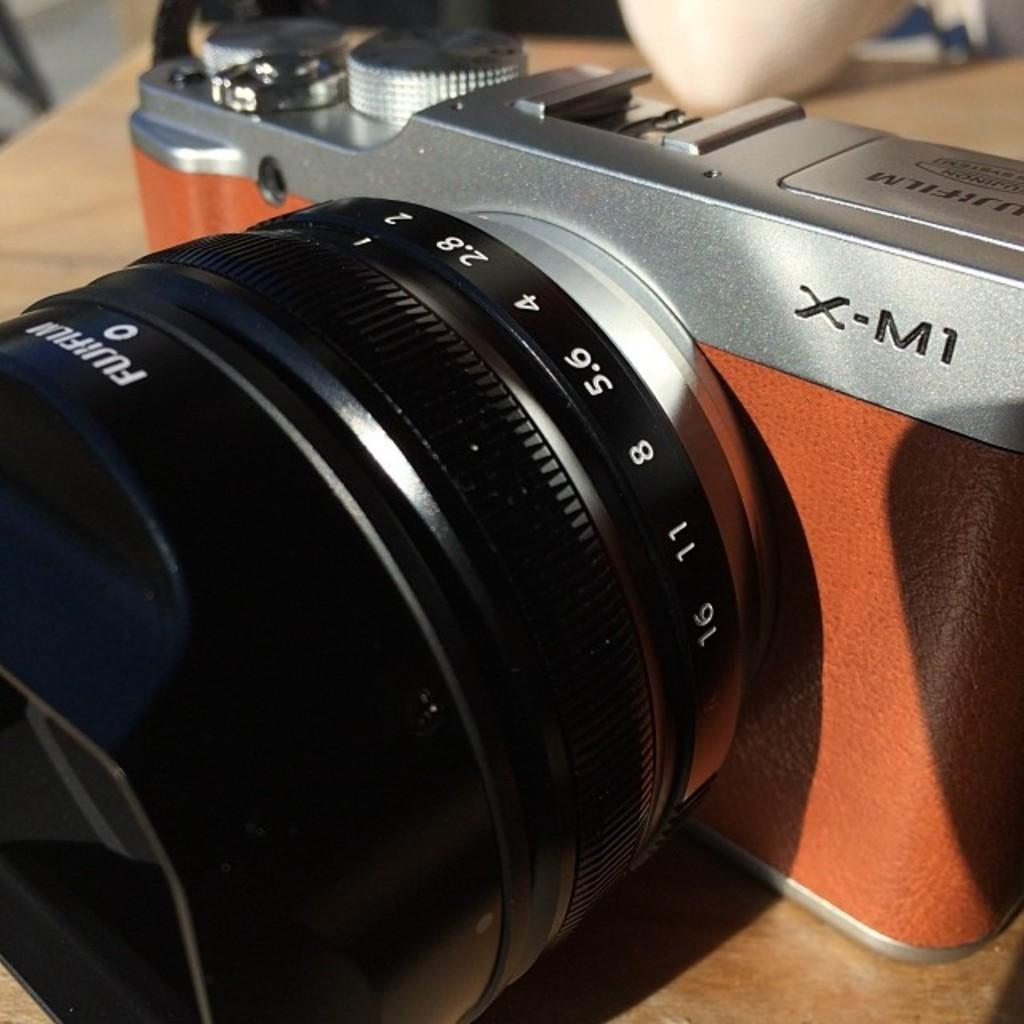What is the main subject of the image? The main subject of the image is a camera. Where is the camera placed in the image? The camera is on a wooden object. Can you describe anything else in the image besides the camera and the wooden object? There is an unspecified object in the top right side of the image. How many visitors are present in the image? There is no indication of any visitors in the image; it only features a camera on a wooden object and an unspecified object in the top right side. 